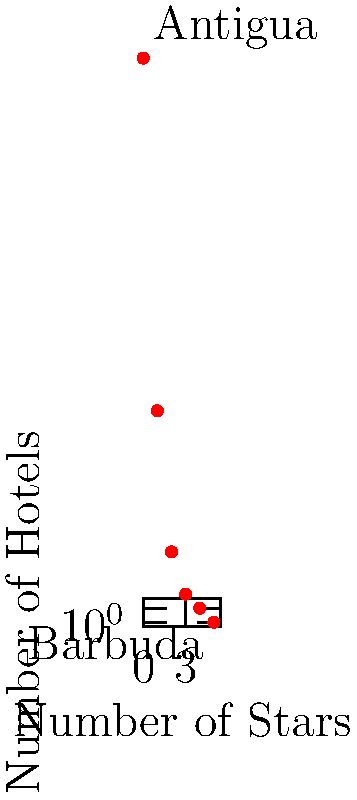The scatter plot shows the distribution of hotel accommodations across Antigua and Barbuda based on their star ratings. What does this graph reveal about the tourism infrastructure differences between the two islands? To interpret this scatter plot and understand the tourism infrastructure differences between Antigua and Barbuda, let's analyze it step-by-step:

1. X-axis representation: The x-axis shows the number of stars, ranging from 0 to 5, indicating hotel ratings.

2. Y-axis representation: The y-axis shows the number of hotels on a logarithmic scale, ranging from 0.5 to 50.

3. Data points:
   - There's a high concentration of hotels (40) at the 0-star rating, likely representing budget accommodations or guesthouses in Antigua.
   - The number of hotels decreases as the star rating increases.
   - There are no 5-star hotels represented on the graph.

4. Antigua vs. Barbuda:
   - The label "Antigua" is placed near the point with the highest number of hotels, suggesting that Antigua has a diverse range of accommodations, particularly in the lower-star categories.
   - The label "Barbuda" is placed near the bottom-right of the graph, indicating very few high-end accommodations.

5. Tourism infrastructure implications:
   - Antigua appears to have a more developed tourism infrastructure with a wide range of accommodations catering to different budget levels.
   - Barbuda seems to have significantly fewer accommodations, possibly focusing on exclusive, high-end properties or eco-tourism.

6. Overall tourism strategy:
   - The graph suggests that Antigua is positioned to cater to a broader range of tourists, from budget travelers to luxury seekers.
   - Barbuda appears to have a more niche market, possibly targeting high-end tourists or those seeking a more exclusive, less developed destination.

This distribution reflects the different tourism development strategies and infrastructure investments between the two islands, with Antigua being the main hub for mass tourism and Barbuda maintaining a more exclusive, less developed profile.
Answer: Antigua has a diverse range of accommodations across star ratings, while Barbuda has fewer, higher-end options, reflecting different tourism development strategies between the islands. 